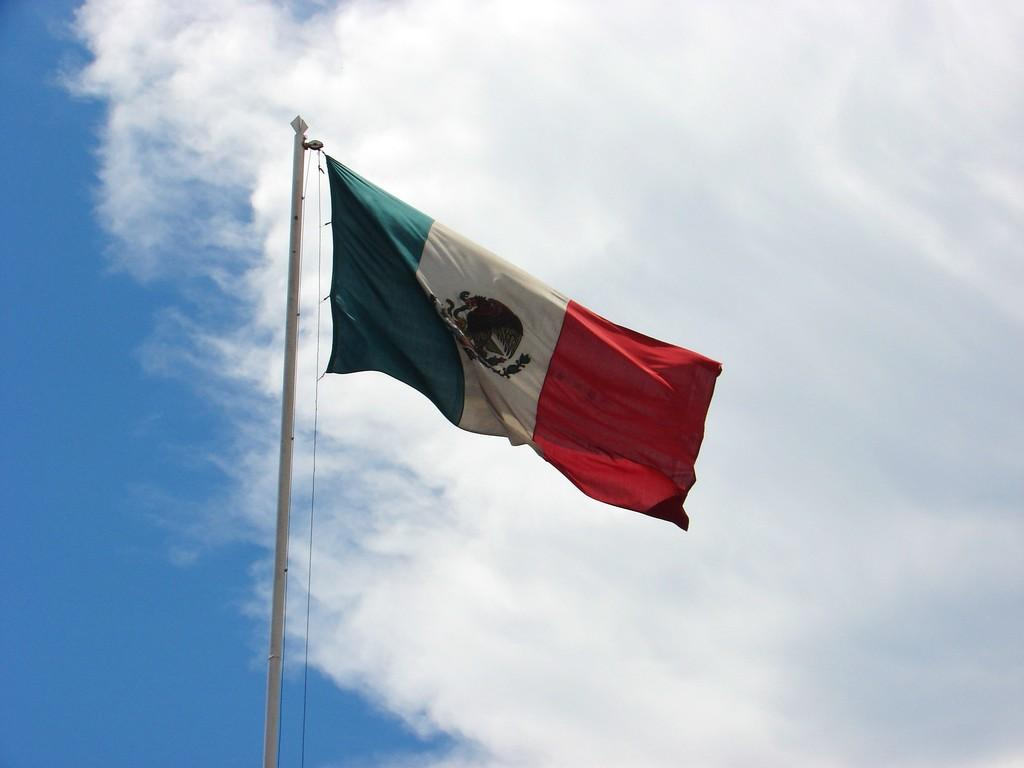What is on the pole in the image? There is a flag on a pole in the image. What can be seen in the background of the image? The sky is visible in the background of the image. What is the condition of the sky in the image? There are clouds in the sky in the image. What type of umbrella is being used to shield the flag from the rain in the image? There is no umbrella present in the image, and the flag is not being shielded from the rain. 